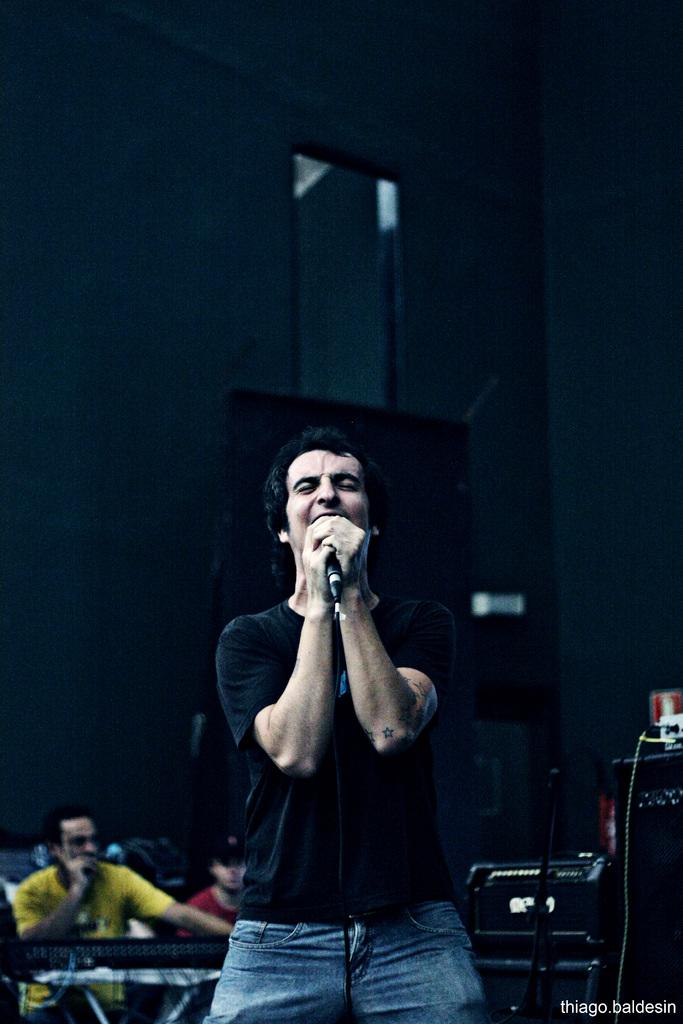What is the person in the image holding? The person is holding a mic in the image. What can be seen in the background of the image? There are musical instruments and other persons in the background of the image. What type of clouds can be seen in the image? There are no clouds visible in the image; it is an indoor setting with no reference to the sky or weather. 